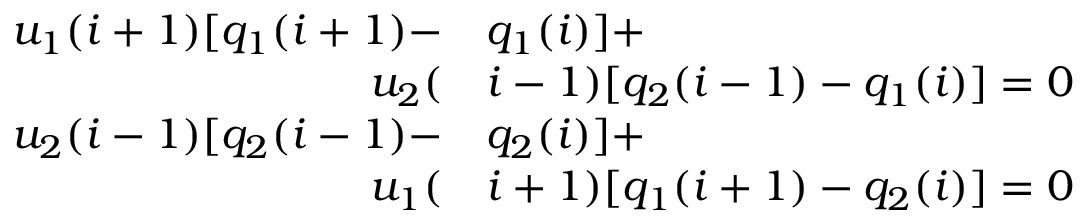Convert formula to latex. <formula><loc_0><loc_0><loc_500><loc_500>\begin{array} { r l } { u _ { 1 } ( i + 1 ) [ q _ { 1 } ( i + 1 ) - } & { q _ { 1 } ( i ) ] + } \\ { u _ { 2 } ( } & { i - 1 ) [ q _ { 2 } ( i - 1 ) - q _ { 1 } ( i ) ] = 0 } \\ { u _ { 2 } ( i - 1 ) [ q _ { 2 } ( i - 1 ) - } & { q _ { 2 } ( i ) ] + } \\ { u _ { 1 } ( } & { i + 1 ) [ q _ { 1 } ( i + 1 ) - q _ { 2 } ( i ) ] = 0 } \end{array}</formula> 